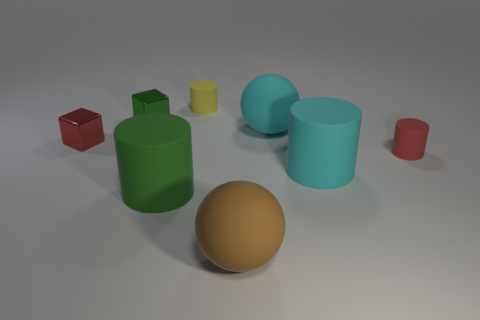Add 2 tiny cylinders. How many objects exist? 10 Subtract all spheres. How many objects are left? 6 Add 7 red metallic blocks. How many red metallic blocks are left? 8 Add 6 big cyan rubber things. How many big cyan rubber things exist? 8 Subtract 0 gray balls. How many objects are left? 8 Subtract all small cubes. Subtract all brown matte objects. How many objects are left? 5 